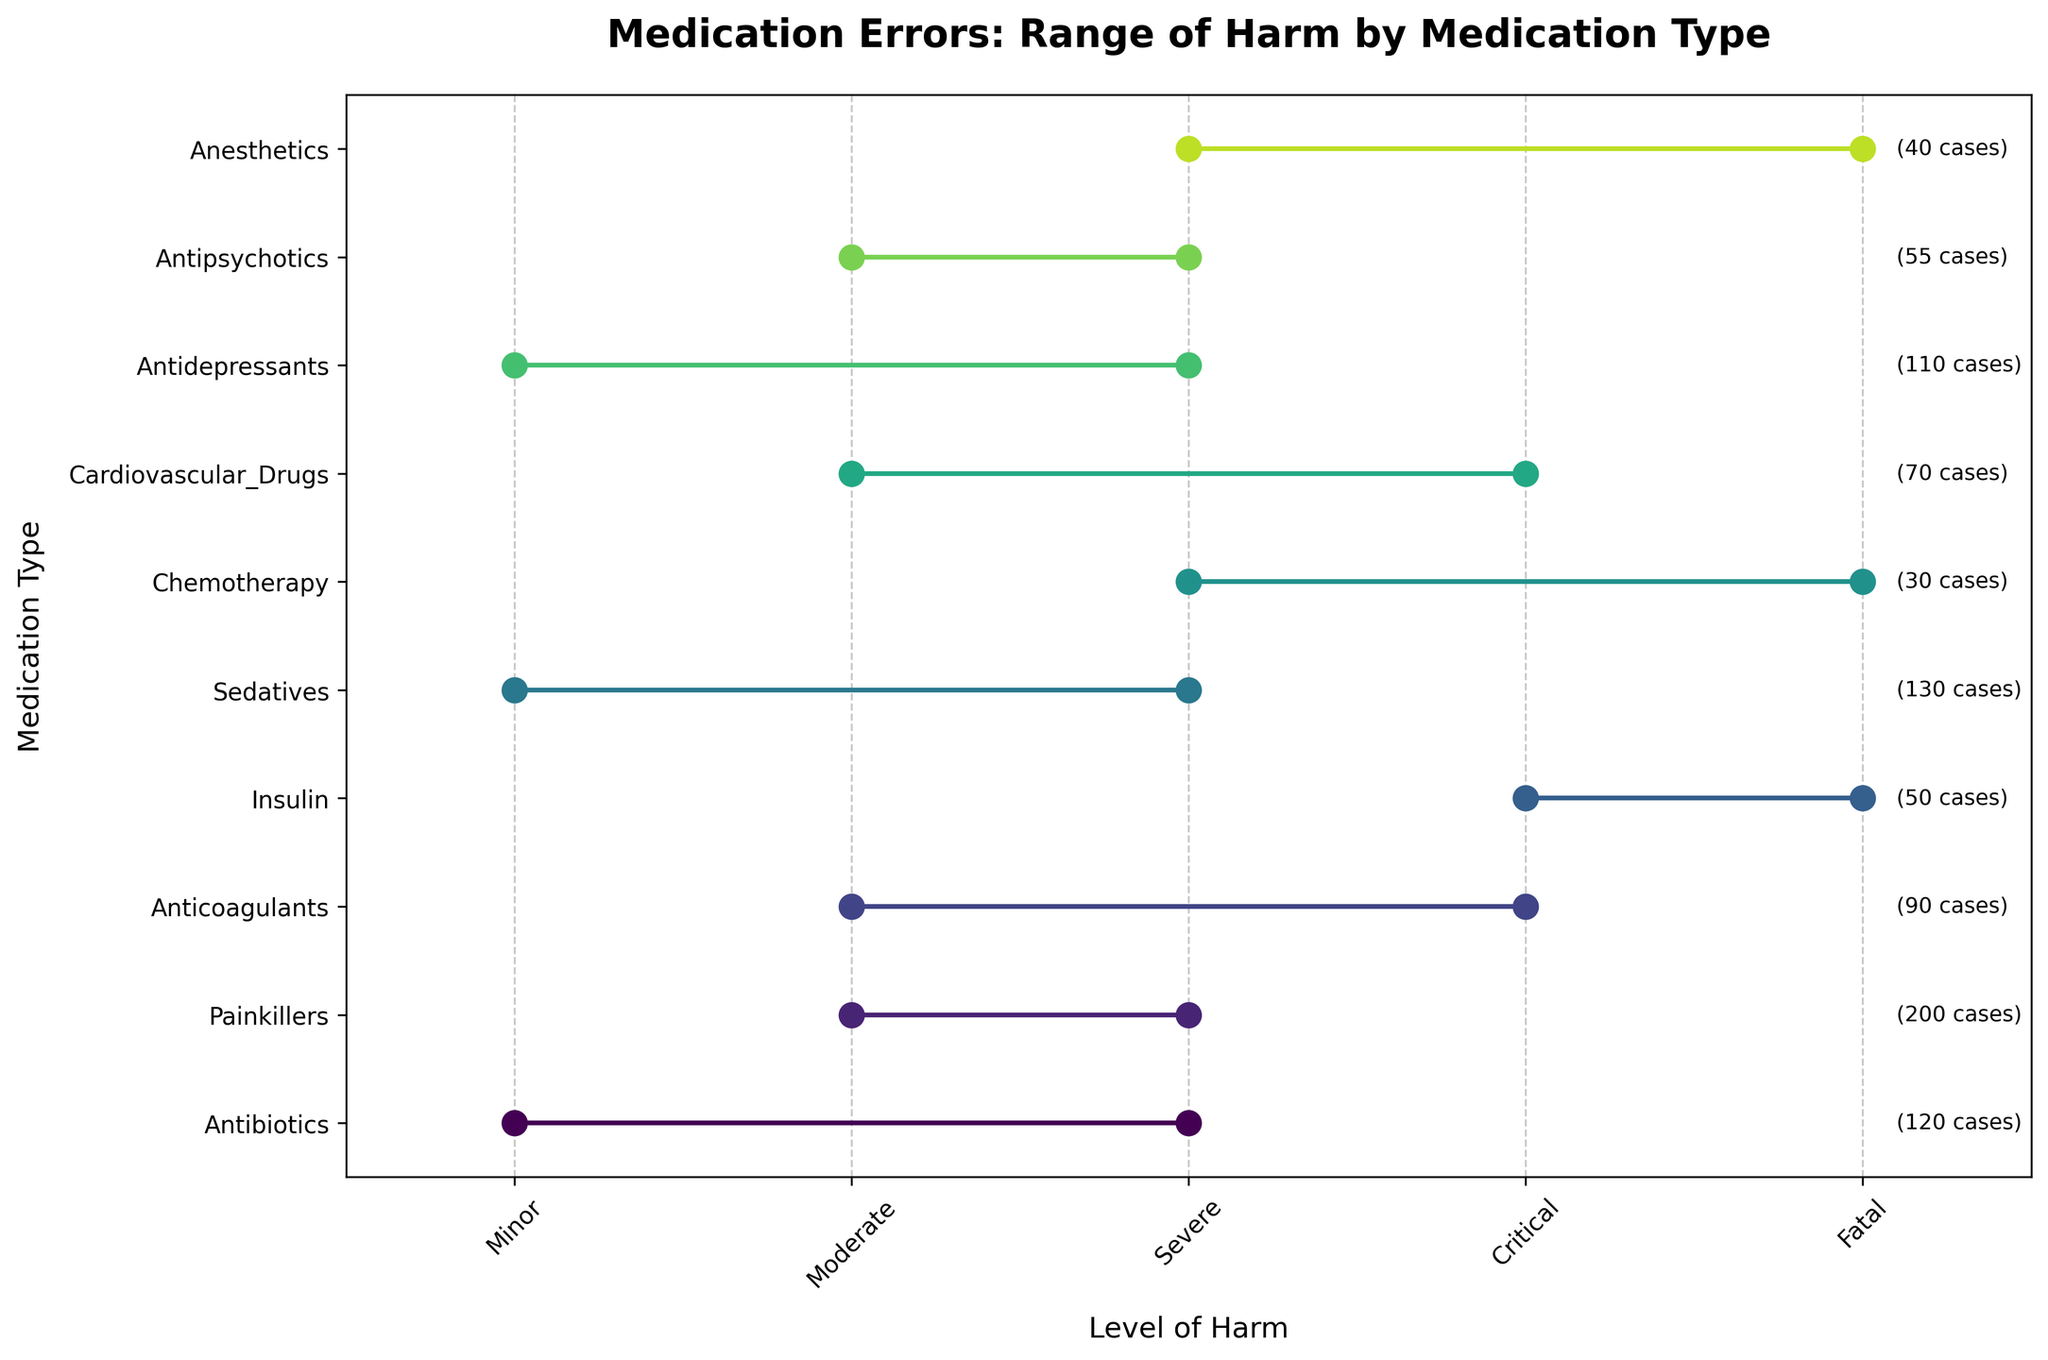What is the title of the plot? The title is typically found at the top of the plot in larger, bold text. In this case, the title reads "Medication Errors: Range of Harm by Medication Type."
Answer: Medication Errors: Range of Harm by Medication Type How many medication types are shown in the plot? The medication types are listed along the vertical axis (y-axis). Counting these labels will give us the number of medication types shown. There are 10 medication types listed.
Answer: 10 Which medication type had the highest number of cases? The number of cases for each medication type is displayed as text next to the corresponding line on the plot. "Painkillers" have the highest number of cases with 200.
Answer: Painkillers What is the range of harm for Insulin errors? The range of harm for each medication type is shown by a horizontal line spanning from the minimum harm to the maximum harm. For Insulin, the line starts at 'Critical' and extends to 'Fatal'.
Answer: Critical to Fatal Which medication types have 'Severe' as the maximum level of harm? The maximum level of harm is the rightmost point of each line. The medication types with 'Severe' as their maximum level of harm are listed where these lines end at 'Severe'. These include Antibiotics, Painkillers, Sedatives, Antidepressants, and Antipsychotics.
Answer: Antibiotics, Painkillers, Sedatives, Antidepressants, Antipsychotics What is the minimum level of harm for Cardiovascular Drugs? The minimum level of harm is the leftmost point of the line for each medication type. For Cardiovascular Drugs, this point is at 'Moderate'.
Answer: Moderate Compare the range of harm for Anticoagulants and Antipsychotics. Which has a broader range? The range of harm is indicated by the span of the line from minimum to maximum harm. Anticoagulants have a range from 'Moderate' to 'Critical', while Antipsychotics range from 'Moderate' to 'Severe'. Thus, Anticoagulants have a broader range of harm.
Answer: Anticoagulants Which medication type has the lowest number of cases? The number of cases for each medication type is displayed next to the corresponding line. "Chemotherapy" has the lowest number of cases with 30.
Answer: Chemotherapy Are there any medication types where the harm ranged from 'Minor' to 'Severe'? The range of harm spanning from 'Minor' to 'Severe' would show a line starting at 'Minor' and ending at 'Severe'. Antibiotics, Sedatives, and Antidepressants have harm ranges from 'Minor' to 'Severe'.
Answer: Antibiotics, Sedatives, Antidepressants 